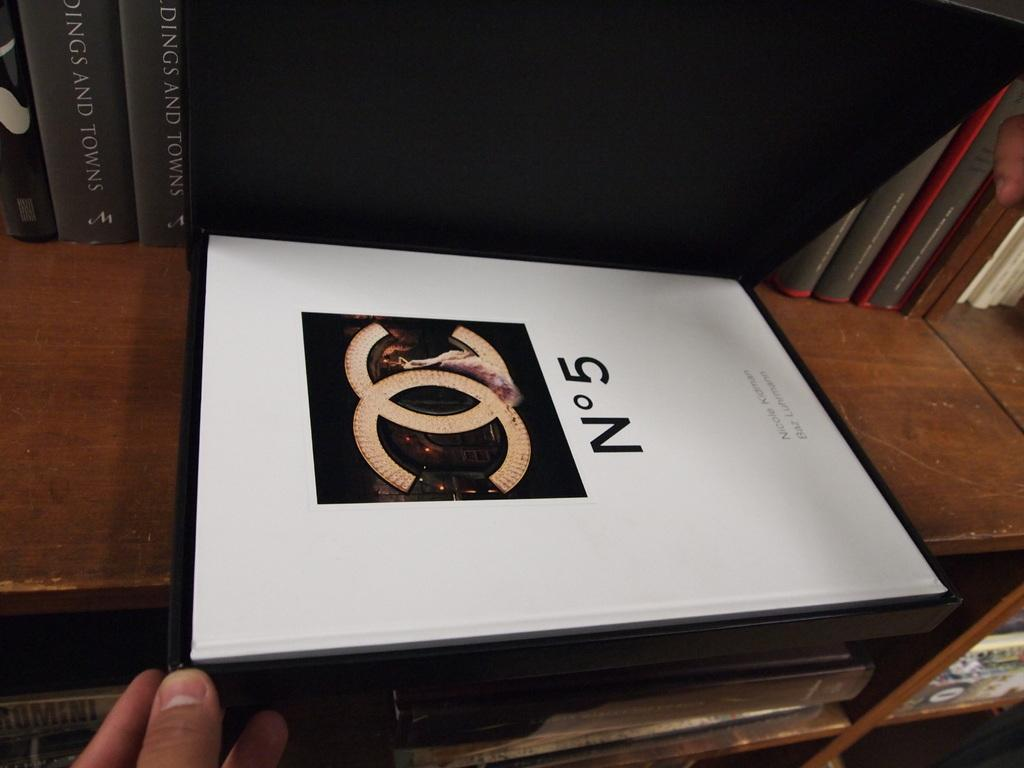Provide a one-sentence caption for the provided image. A Chanel N05 box that is sitting on a shelf. 